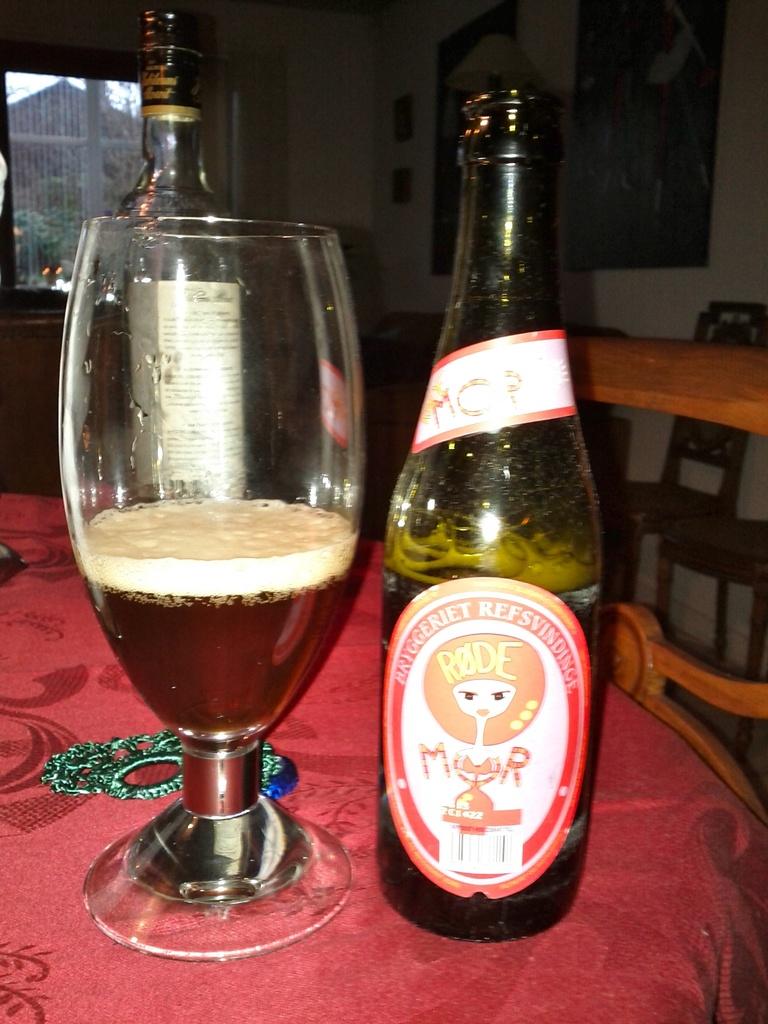What brand of beer is this?
Give a very brief answer. Rode. 